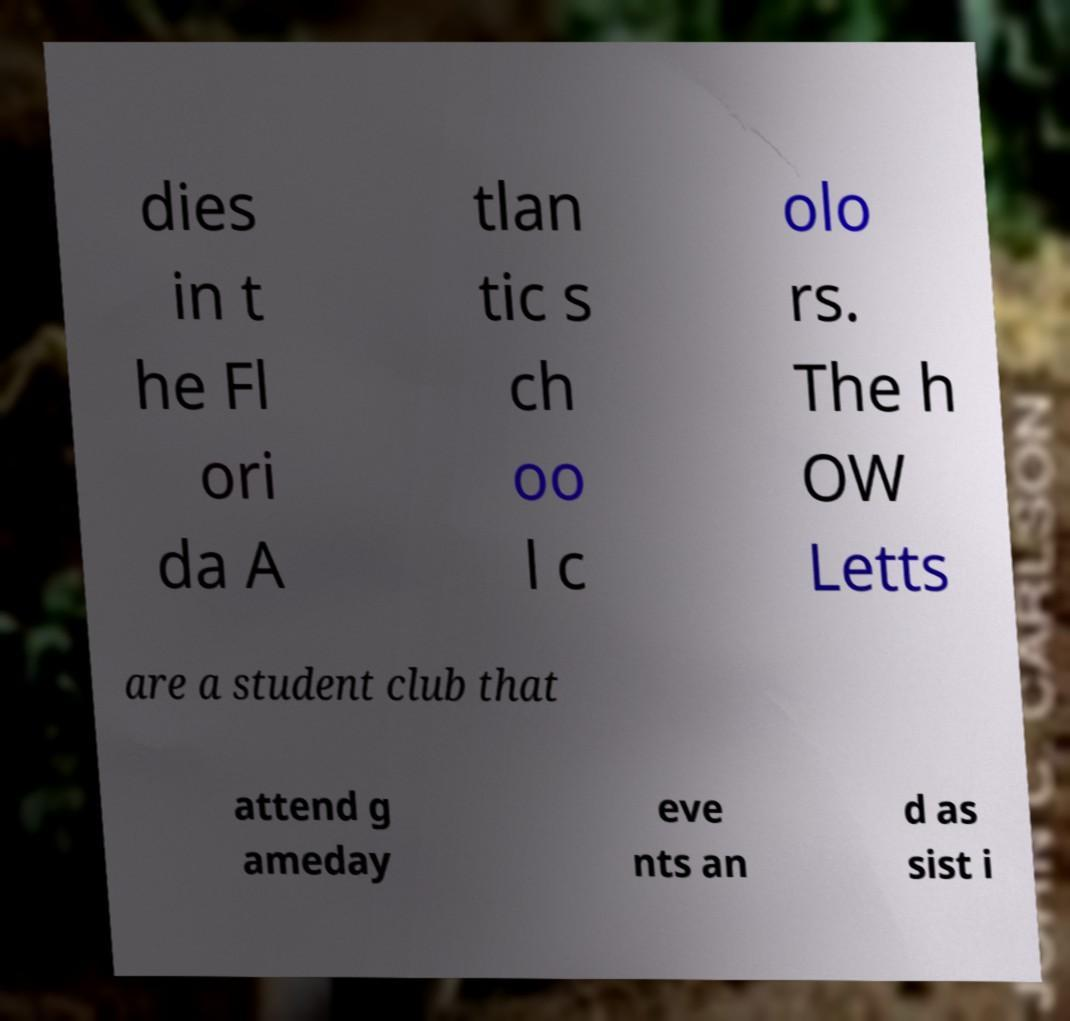Can you accurately transcribe the text from the provided image for me? dies in t he Fl ori da A tlan tic s ch oo l c olo rs. The h OW Letts are a student club that attend g ameday eve nts an d as sist i 